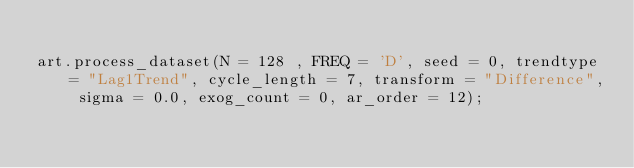<code> <loc_0><loc_0><loc_500><loc_500><_Python_>
art.process_dataset(N = 128 , FREQ = 'D', seed = 0, trendtype = "Lag1Trend", cycle_length = 7, transform = "Difference", sigma = 0.0, exog_count = 0, ar_order = 12);</code> 